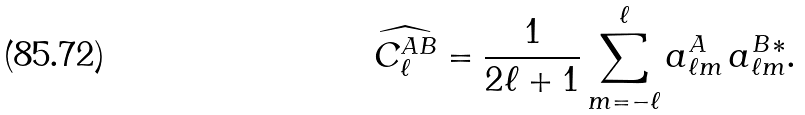Convert formula to latex. <formula><loc_0><loc_0><loc_500><loc_500>\widehat { C _ { \ell } ^ { A B } } = \frac { 1 } { 2 \ell + 1 } \sum _ { m = - \ell } ^ { \ell } a _ { \ell m } ^ { A } \, a _ { \ell m } ^ { B \, * } .</formula> 